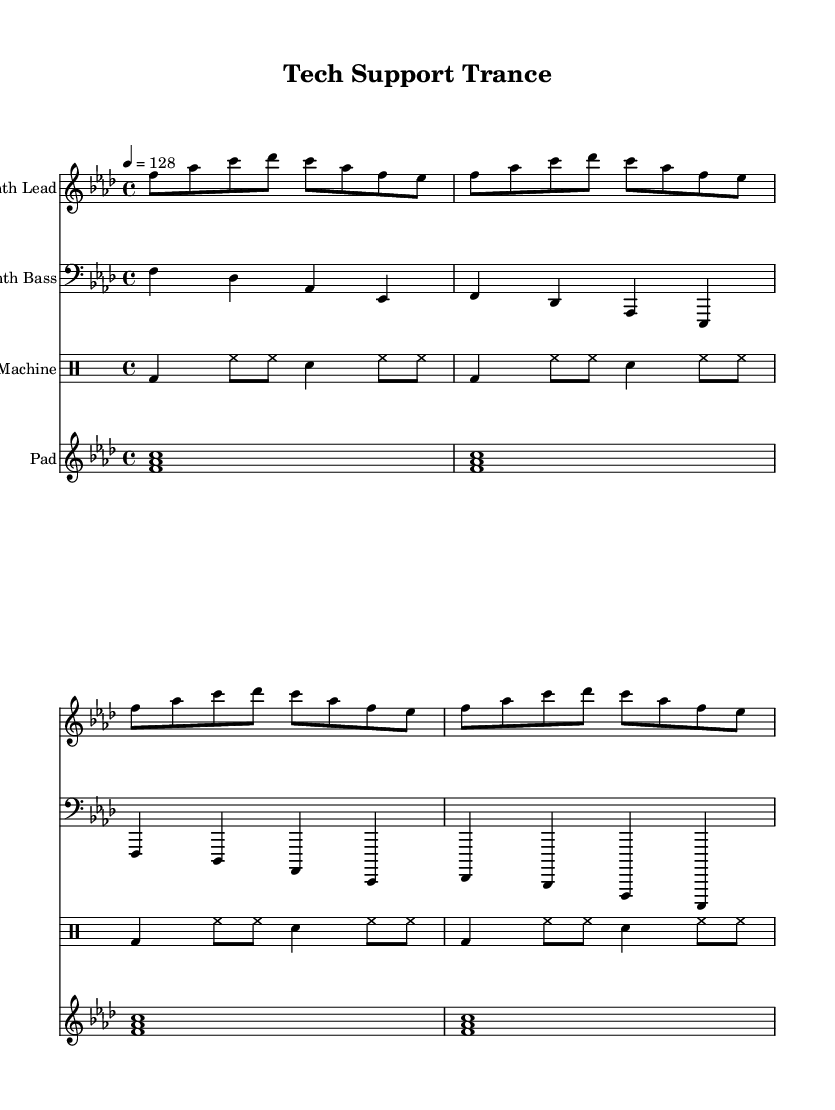What is the key signature of this music? The key signature appears in the beginning of the score, which indicates there are four flats in the key signature, corresponding to F minor.
Answer: F minor What is the time signature of this music? The time signature is found at the beginning of the score and indicates that there are four beats per measure, or 4/4 time.
Answer: 4/4 What is the tempo marking for this piece? The tempo marking is specified in the score, showing that it is set at 128 beats per minute.
Answer: 128 How many measures are there in the synth lead section? To determine this, we count the number of measures in the synth lead part, which shows there are a total of four measures played in sequence.
Answer: 4 What types of instruments are featured in this score? The score includes four different parts: Synth Lead, Synth Bass, Drum Machine, and Pad, each denoted at the start of their respective sections.
Answer: Synth Lead, Synth Bass, Drum Machine, Pad What rhythm pattern is used in the drum section? The drum section uses a consistent pattern of bass drum and hi-hat sounds, indicated with specific note symbols that repeat every measure.
Answer: Bass drum and hi-hat pattern What is the most prominent feature of the melody in the synth lead? The melody in the synth lead primarily consists of ascending and descending pitches that create a lively, upbeat feel, characterized by noticeable note repetitions.
Answer: Ascending and descending pitches 